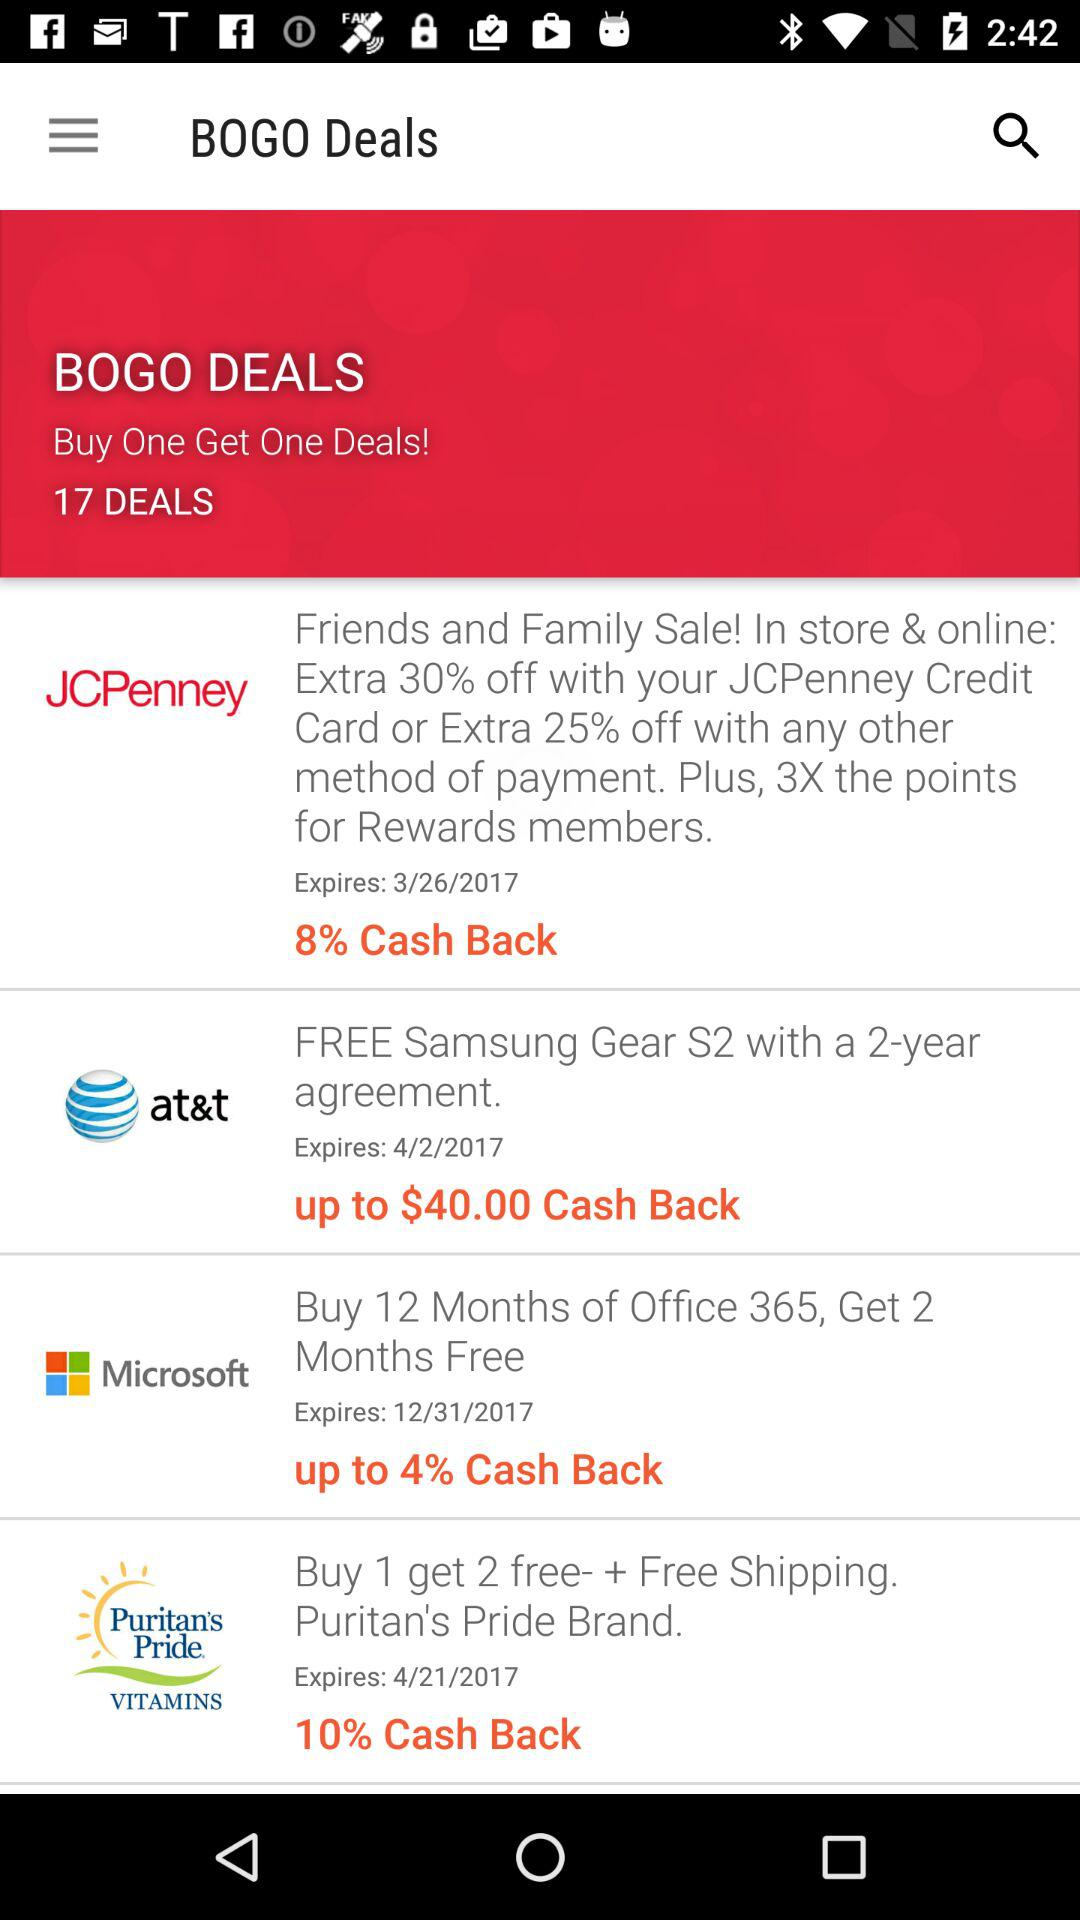What is the highest cash back percentage offered for any of the deals?
Answer the question using a single word or phrase. 10% 